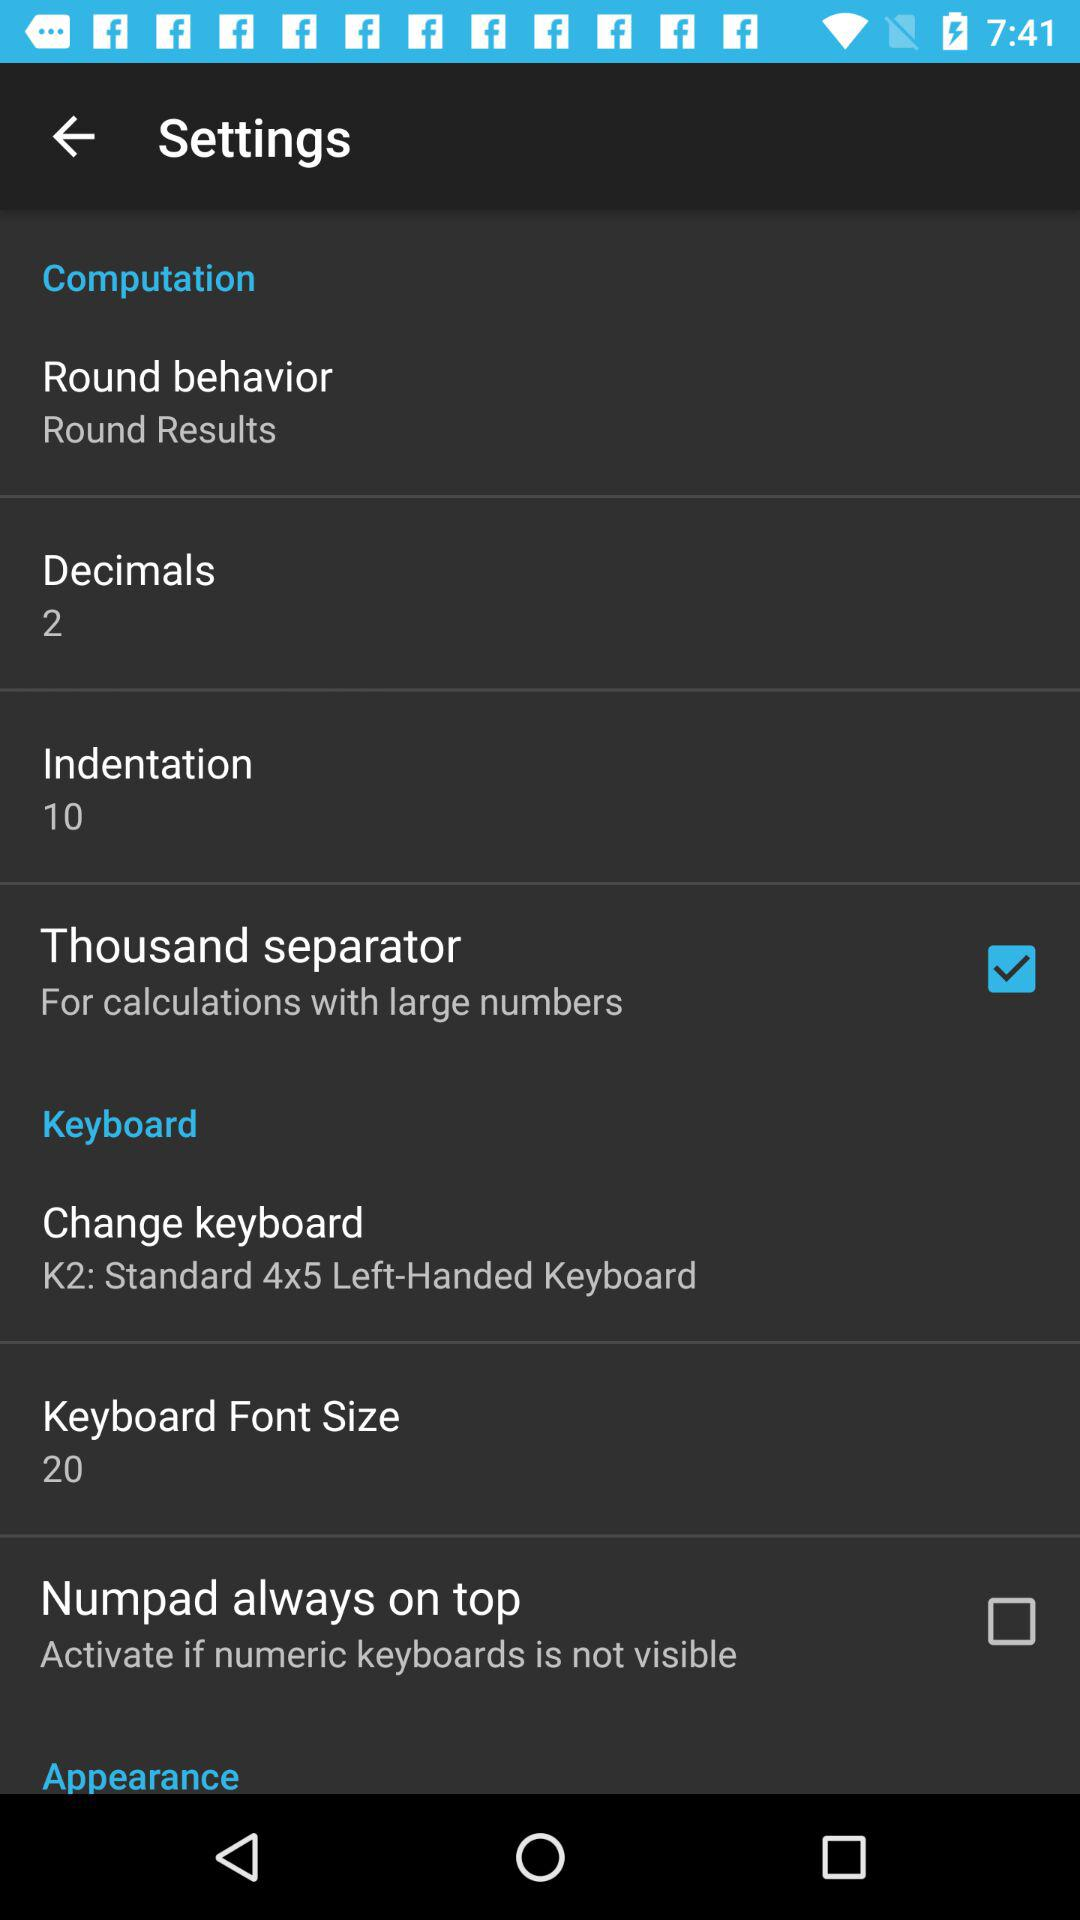How many decimals are there? There are 2 decimals. 